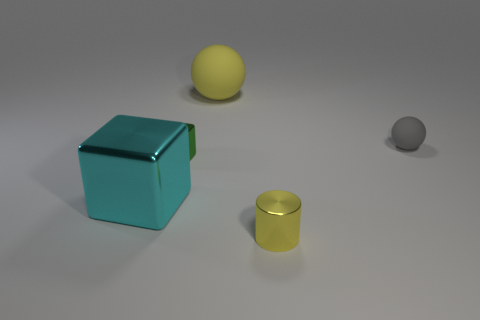The tiny shiny object that is the same color as the big sphere is what shape?
Give a very brief answer. Cylinder. There is a sphere that is to the right of the big thing that is behind the small gray object; what is its size?
Your answer should be very brief. Small. What number of spheres are yellow rubber objects or yellow objects?
Your response must be concise. 1. There is a matte ball that is the same size as the yellow shiny cylinder; what is its color?
Offer a terse response. Gray. There is a matte thing that is behind the object to the right of the tiny yellow metal cylinder; what is its shape?
Your answer should be very brief. Sphere. Do the yellow object behind the yellow shiny thing and the small rubber sphere have the same size?
Make the answer very short. No. What number of other objects are the same material as the gray thing?
Give a very brief answer. 1. What number of green things are matte balls or small spheres?
Provide a short and direct response. 0. There is a rubber thing that is the same color as the metal cylinder; what is its size?
Your answer should be compact. Large. There is a large metallic object; what number of large things are on the left side of it?
Give a very brief answer. 0. 